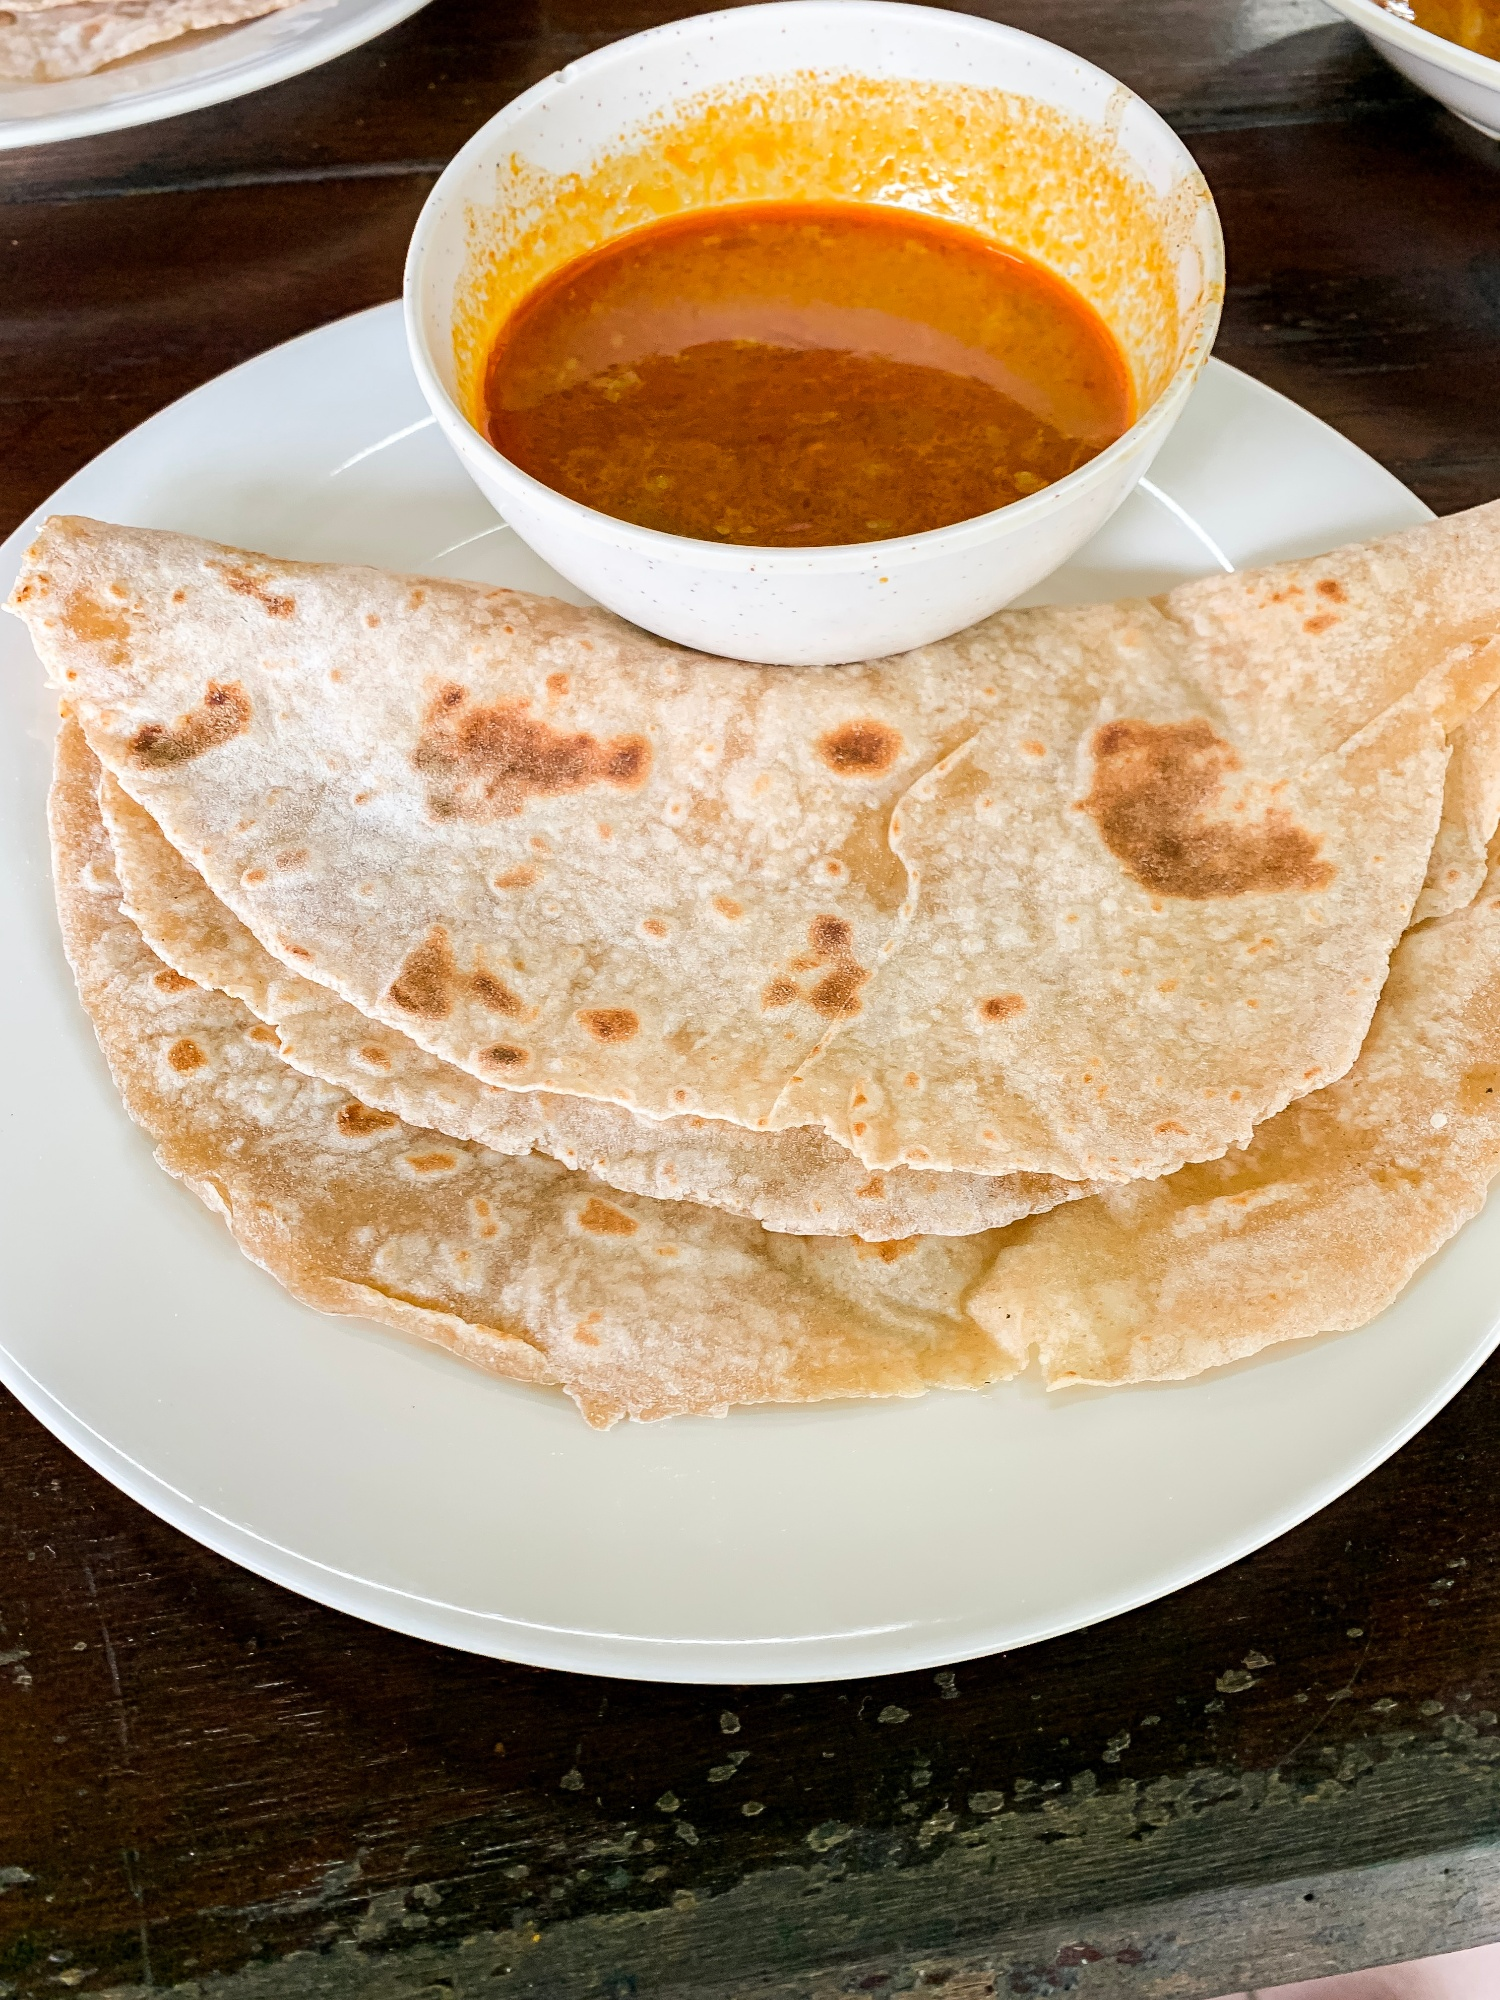What fictional scenario could you imagine involving this meal? Imagine this scene: a traveler from a distant galaxy lands on Earth, drawn by the aromatic scents of spices. Intrigued by the local Earthling cuisine, the traveler makes its way to a modest Indian village. The villagers, curious but welcoming, invite the traveler to a communal meal. They serve roti and curry, explaining its cultural importance and the meaning behind each spice blend. Through this meal, the traveler learns about the Earth's diverse cultures and shares tales from its own planet, where food is synthesized and lacks the depth of flavor found in Earth’s cuisine. This meal becomes a bridge between worlds, fostering intergalactic friendship and understanding. Can you create a detailed story around this scenario? In the year 3050, Earth was visited by an interstellar traveler, Zandor, from the planet Elyria. Zandor was an ambassador, seeking to learn about Earth's cultures and traditions. Equipped with a translator device, Zandor could communicate in any of Earth's languages. Landing in a serene Indian village, the scent of spices led Zandor to a bustling market. The villagers, amazed by Zandor's presence, welcomed the alien with curiosity and kindness. They invited Zandor to a meal, featuring freshly made roti and a fragrant curry. The village elder, Asha, explained the significance of each ingredient used. She talked about how roti is made from locally sourced whole wheat and how the spices in the curry—cumin, coriander, turmeric, and chili—are traditional recipes passed down through generations. As Zandor sharegpt4v/sampled the meal, it was amazed by the complex flavors, unlike anything experienced on Elyria, where food was nutrient-based but flavorless due to its synthetic nature. Deeply moved, Zandor shared how Elyrians consumed food for sustenance without a cultural attachment. This humble meal became a learning experience for Zandor, fostering a newfound respect for Earth's culinary traditions. The villagers and Zandor shared stories, with Zandor detailing the advanced technologies of Elyria and marveling at Earth's ability to preserve culture through something as simple yet profound as a meal. This encounter laid the foundation for a cultural exchange program between Earth and Elyria, spreading knowledge across the stars. 